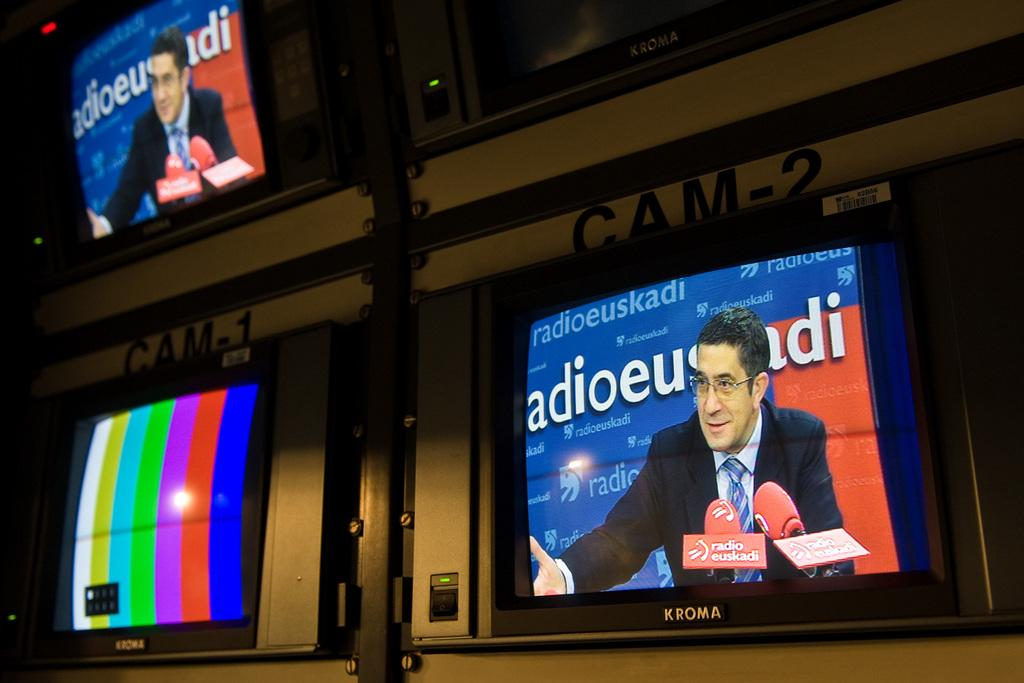<image>
Create a compact narrative representing the image presented. TV Monitors have the words Cam-1 and Cam-2 above them. 